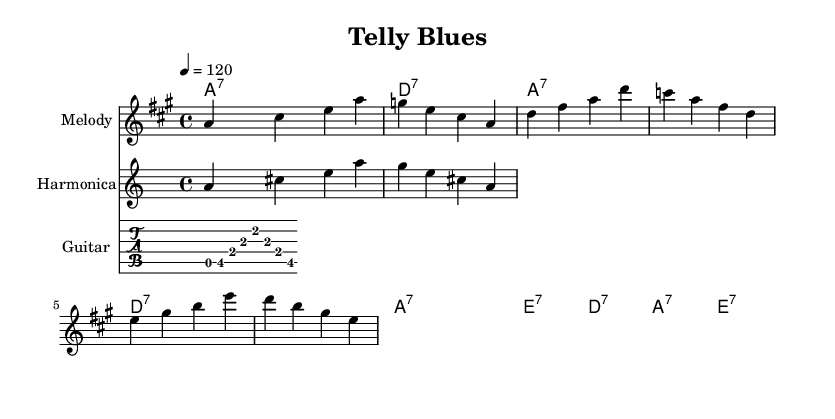What is the key signature of this music? The key signature is A major, which has three sharps (F#, C#, and G#). This is indicated at the beginning of the staff in the sheet music.
Answer: A major What is the time signature of this piece? The time signature is 4/4, meaning there are four beats in a measure and the quarter note gets one beat. This can be found at the beginning of the piece as well.
Answer: 4/4 What is the tempo marking for this music? The tempo marking is quarter note equals 120, indicating that the piece should be played at a moderate tempo of 120 beats per minute. This is stated above the staff in the sheet music.
Answer: 120 What type of blues is this music characterized as? The music is characterized as electric blues, which is indicated by its upbeat tempo and use of electric instruments such as guitar and harmonica in the arrangement.
Answer: Electric blues How many measures are in the melody section? The melody section contains a total of 12 measures, which can be counted by looking at the number of groupings of notes within the staff.
Answer: 12 Which chord is predominantly used in the progression? The predominant chord used in the progression is A7. This can be identified as it appears multiple times in the chord names provided alongside the music.
Answer: A7 What instruments are specified in the score? The instruments specified in the score are melody, harmonica, and guitar. These are labeled at the beginning of each staff in the music sheet.
Answer: Melody, harmonica, guitar 